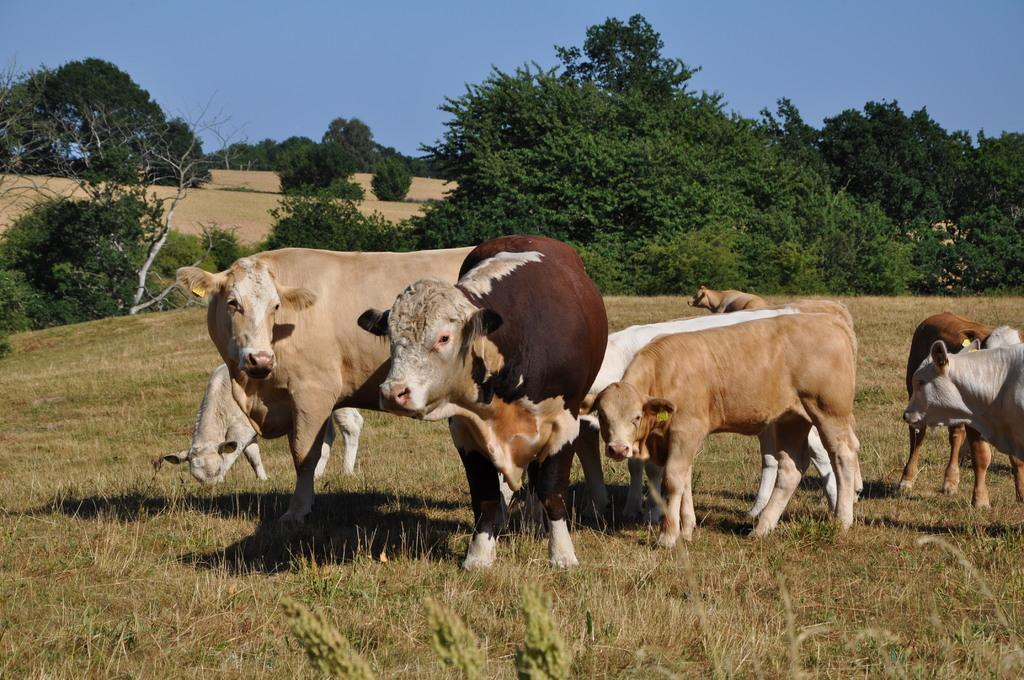What type of ground is visible in the image? There is grass ground in the image. What can be observed on the grass ground? There are shadows and cows standing on the grass ground. What is visible in the background of the image? There are trees and the sky visible in the background of the image. Where are the cherries hanging in the image? There are no cherries present in the image. What type of receipt can be seen on the grass ground? There is no receipt visible in the image. 